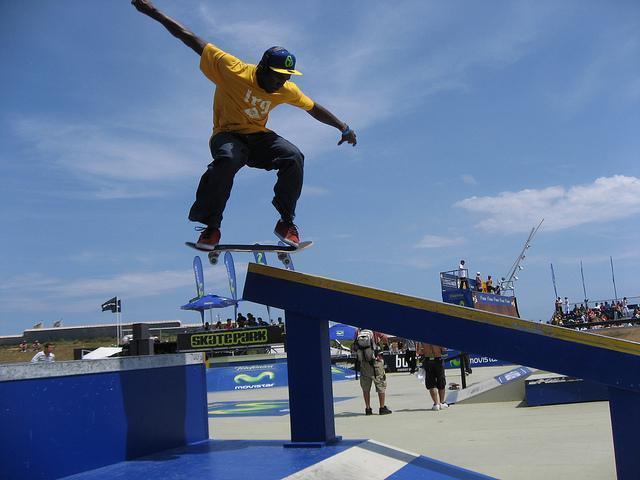How many people can be seen?
Give a very brief answer. 2. 